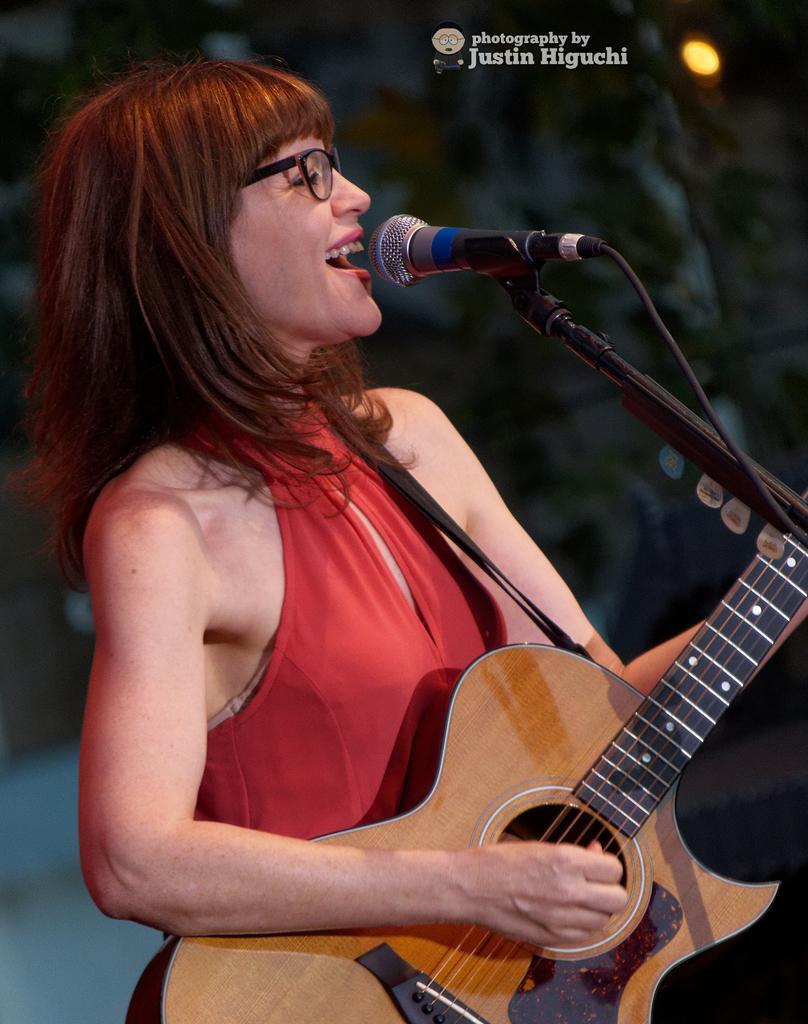How would you summarize this image in a sentence or two? The girl in red dress wore spectacles holds a guitar and sings in-front of a mic. 